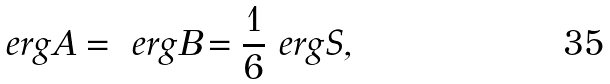Convert formula to latex. <formula><loc_0><loc_0><loc_500><loc_500>\ e r g { A } = \ e r g { B } = \frac { 1 } { 6 } \ e r g { S } ,</formula> 